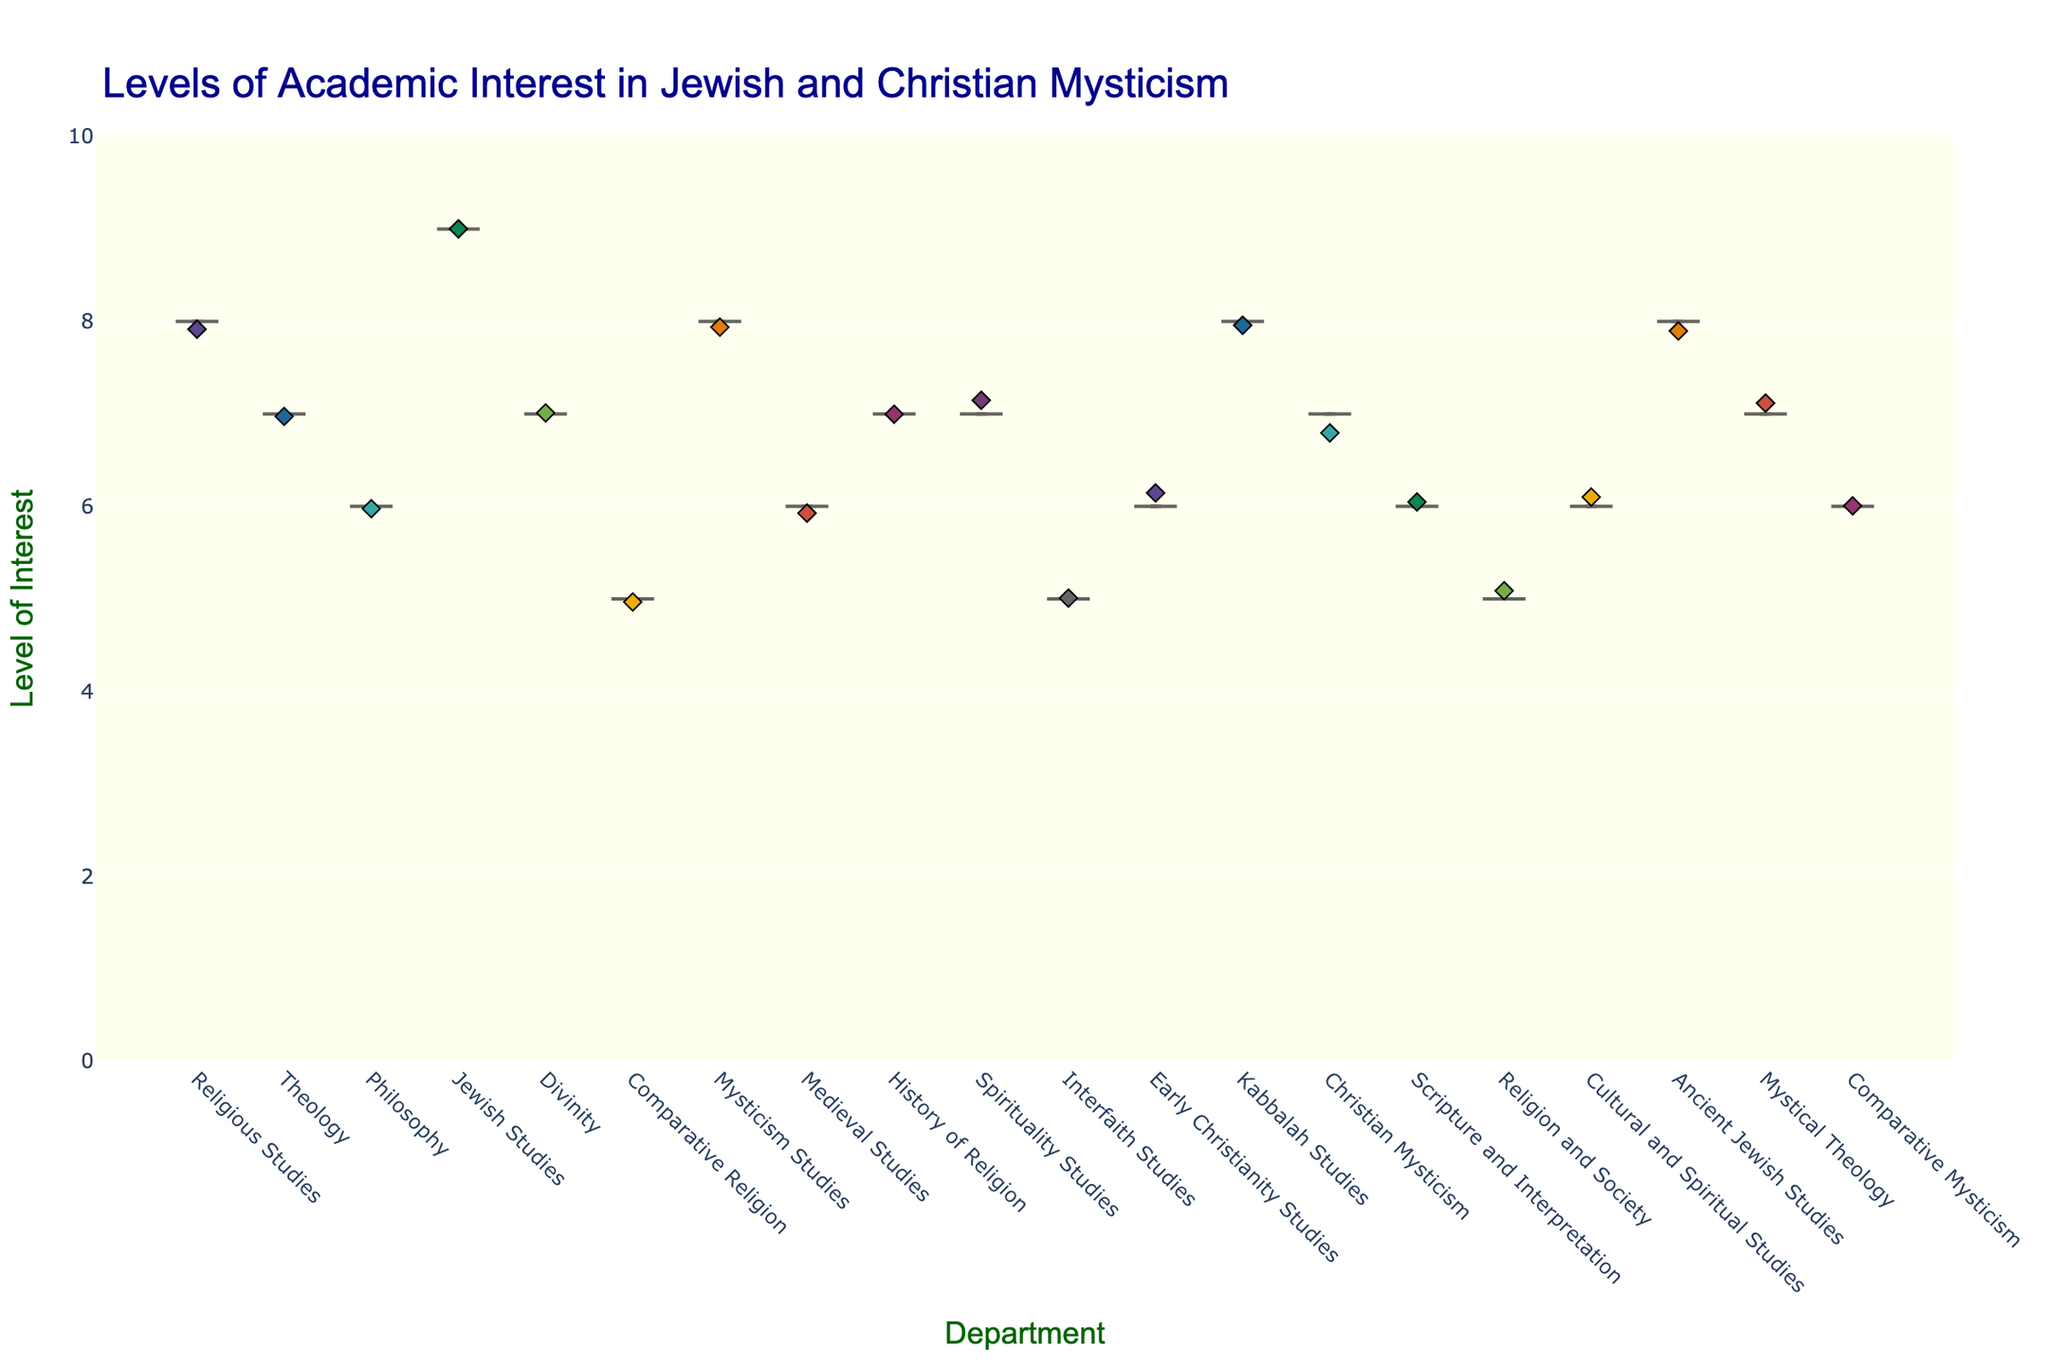What is the title of the figure? The title of the figure is displayed at the top and usually describes the content or purpose of the plot. In this case, it reads "Levels of Academic Interest in Jewish and Christian Mysticism".
Answer: Levels of Academic Interest in Jewish and Christian Mysticism How many data points are there for the 'Jewish Studies' department? The number of data points can be determined by the jittered points (diamonds) displayed for the 'Jewish Studies' department. Each point represents a data entry. Upon observing, there is one data point for 'Jewish Studies'.
Answer: 1 Which department shows the highest level of interest? To identify the department with the highest level of interest, observe the y-axis markings and look for the highest point among the departments. 'Jewish Studies' at New York University has the highest level of interest, marked at 9.
Answer: Jewish Studies What is the range of interest levels depicted in the figure? The range is determined by the minimum and maximum levels of interest marked on the y-axis. Observing the y-axis, the lowest interest level is 5, while the highest is 9. So, the range is 4.
Answer: 4 Which department has the most variability in the levels of interest? Variability in levels of interest can be inferred from the width of the violin plots. The wider the plot, the more variable the data. Observing the figure, the 'Jewish Studies' department displays a broad spread, indicating the most variability.
Answer: Jewish Studies Which two universities have an identical level of interest in 'Divinity'? To find matching interest levels across universities within the same department, examine the jitter points. 'Divinity' at both University of Chicago and University of Notre Dame shows an interest level of 7.
Answer: University of Chicago and University of Notre Dame Which department at Georgetown University has a level of interest, and what is it? Examining the plotted points and referring to the specific colors or department names associated with Georgetown University reveals that 'Interfaith Studies' has a level of interest of 5.
Answer: Interfaith Studies, 5 Is the mean level of interest higher in 'Christian Mysticism' or 'Kabbalah Studies'? Refer to the mean line (solid line) inside the violin plots. Observing these lines, the mean level of interest in 'Kabbalah Studies' (Brandeis University) is 8, whereas 'Christian Mysticism' (Durham University) is 7.
Answer: 'Kabbalah Studies' How does the interest in 'Mysticism Studies' at Hebrew University of Jerusalem compare to 'Comparative Religion' at University of Cambridge? Compare the y-axis values of the jitter points for these departments. 'Mysticism Studies' at Hebrew University of Jerusalem has an interest level of 8, which is higher than 'Comparative Religion' at University of Cambridge with an interest level of 5.
Answer: 8 is higher than 5 What color represents 'University of Haifa' in the jittered points, and for which department is it plotted? Inspect the jittered points for uniqueness in color representation. The orange color represents 'University of Haifa' and it is plotted for the 'Ancient Jewish Studies' department.
Answer: Orange, Ancient Jewish Studies 